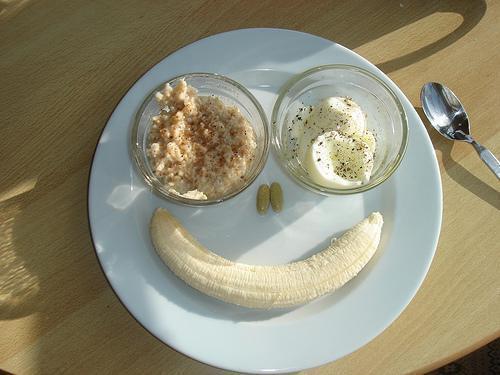How many bowls can be seen?
Give a very brief answer. 2. How many people are wearing blue shirt?
Give a very brief answer. 0. 